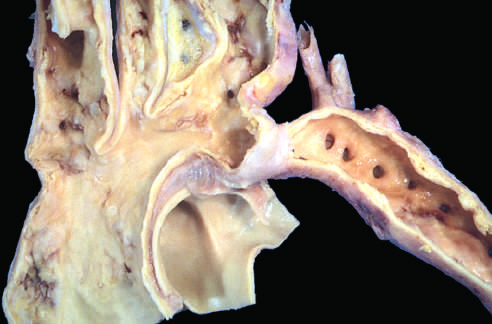re thrombus in the left and right ventricular apices to the left of the coarctation?
Answer the question using a single word or phrase. No 